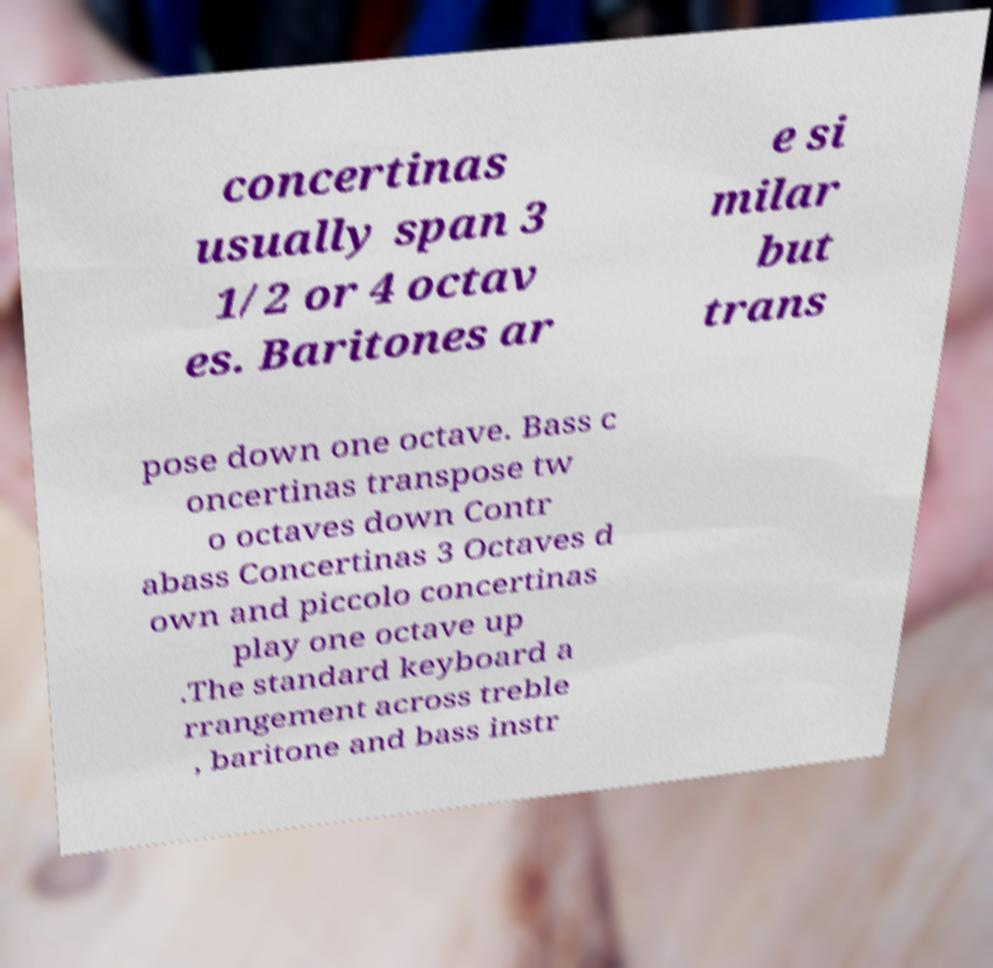What messages or text are displayed in this image? I need them in a readable, typed format. concertinas usually span 3 1/2 or 4 octav es. Baritones ar e si milar but trans pose down one octave. Bass c oncertinas transpose tw o octaves down Contr abass Concertinas 3 Octaves d own and piccolo concertinas play one octave up .The standard keyboard a rrangement across treble , baritone and bass instr 